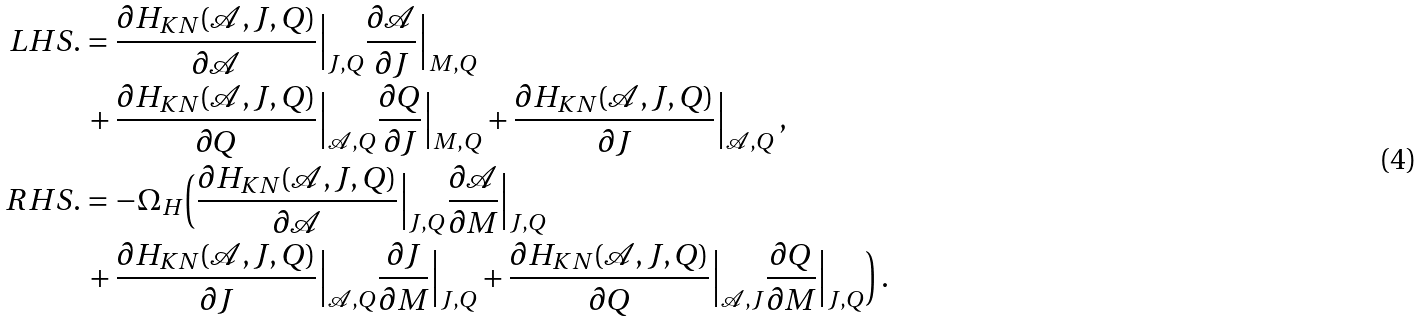<formula> <loc_0><loc_0><loc_500><loc_500>L H S . & = \frac { \partial H _ { K N } ( \mathcal { A } , J , Q ) } { \partial \mathcal { A } } \Big | _ { J , Q } \frac { \partial \mathcal { A } } { \partial J } \Big | _ { M , Q } \\ & \, + \frac { \partial H _ { K N } ( \mathcal { A } , J , Q ) } { \partial Q } \Big | _ { \mathcal { A } , Q } \frac { \partial Q } { \partial J } \Big | _ { M , Q } + \frac { \partial H _ { K N } ( \mathcal { A } , J , Q ) } { \partial J } \Big | _ { \mathcal { A } , Q } \, , \\ R H S . & = - \Omega _ { H } \Big ( \frac { \partial H _ { K N } ( \mathcal { A } , J , Q ) } { \partial \mathcal { A } } \Big | _ { J , Q } \frac { \partial \mathcal { A } } { \partial M } \Big | _ { J , Q } \\ & \, + \frac { \partial H _ { K N } ( \mathcal { A } , J , Q ) } { \partial J } \Big | _ { \mathcal { A } , Q } \frac { \partial J } { \partial M } \Big | _ { J , Q } + \frac { \partial H _ { K N } ( \mathcal { A } , J , Q ) } { \partial Q } \Big | _ { \mathcal { A } , J } \frac { \partial Q } { \partial M } \Big | _ { J , Q } \Big ) \, .</formula> 